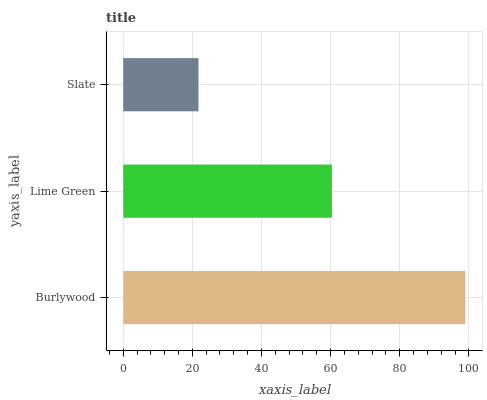Is Slate the minimum?
Answer yes or no. Yes. Is Burlywood the maximum?
Answer yes or no. Yes. Is Lime Green the minimum?
Answer yes or no. No. Is Lime Green the maximum?
Answer yes or no. No. Is Burlywood greater than Lime Green?
Answer yes or no. Yes. Is Lime Green less than Burlywood?
Answer yes or no. Yes. Is Lime Green greater than Burlywood?
Answer yes or no. No. Is Burlywood less than Lime Green?
Answer yes or no. No. Is Lime Green the high median?
Answer yes or no. Yes. Is Lime Green the low median?
Answer yes or no. Yes. Is Burlywood the high median?
Answer yes or no. No. Is Burlywood the low median?
Answer yes or no. No. 